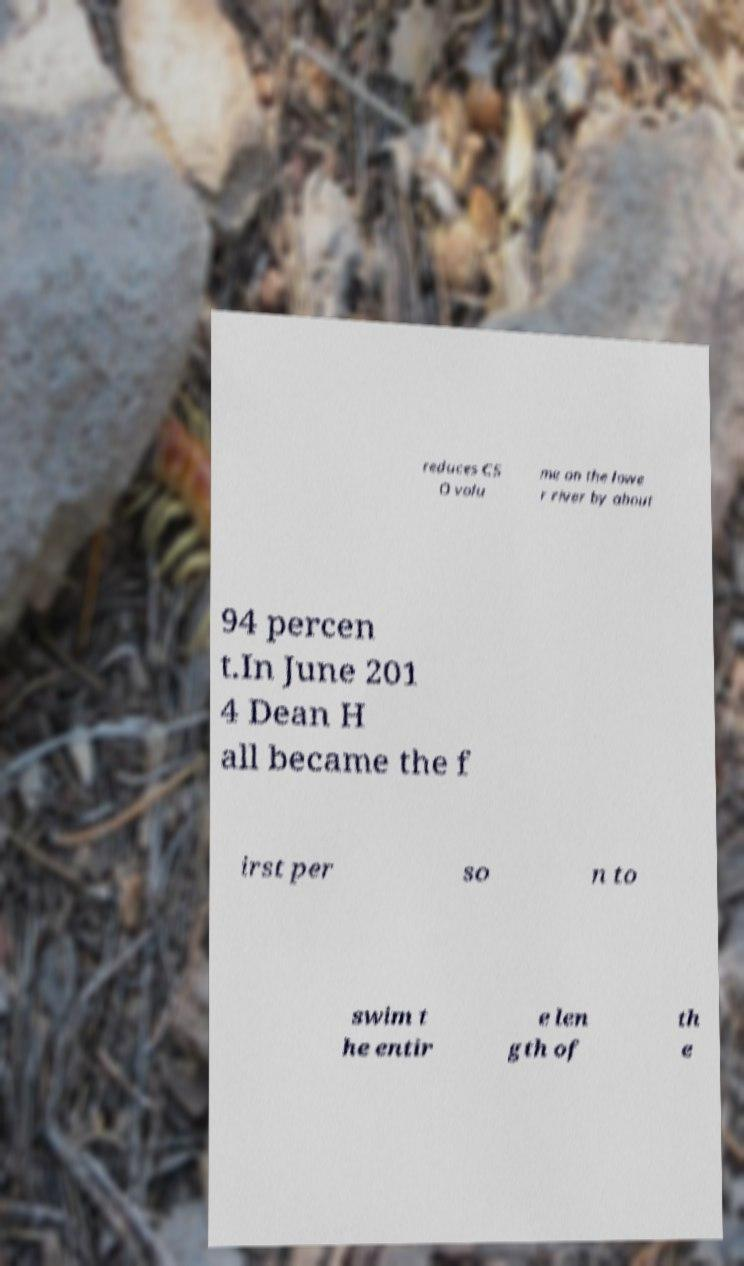Can you accurately transcribe the text from the provided image for me? reduces CS O volu me on the lowe r river by about 94 percen t.In June 201 4 Dean H all became the f irst per so n to swim t he entir e len gth of th e 